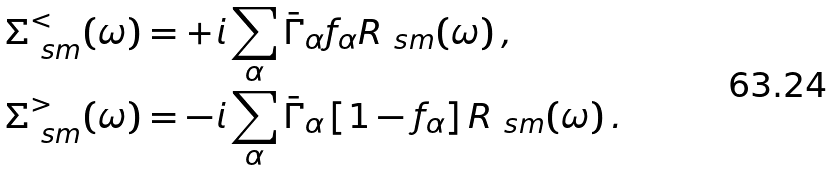Convert formula to latex. <formula><loc_0><loc_0><loc_500><loc_500>\Sigma _ { \ s m } ^ { < } ( \omega ) & = + i \sum _ { \alpha } \bar { \Gamma } _ { \alpha } f _ { \alpha } R _ { \ s m } ( \omega ) \, , \\ \Sigma _ { \ s m } ^ { > } ( \omega ) & = - i \sum _ { \alpha } \bar { \Gamma } _ { \alpha } \left [ 1 - f _ { \alpha } \right ] R _ { \ s m } ( \omega ) \, .</formula> 